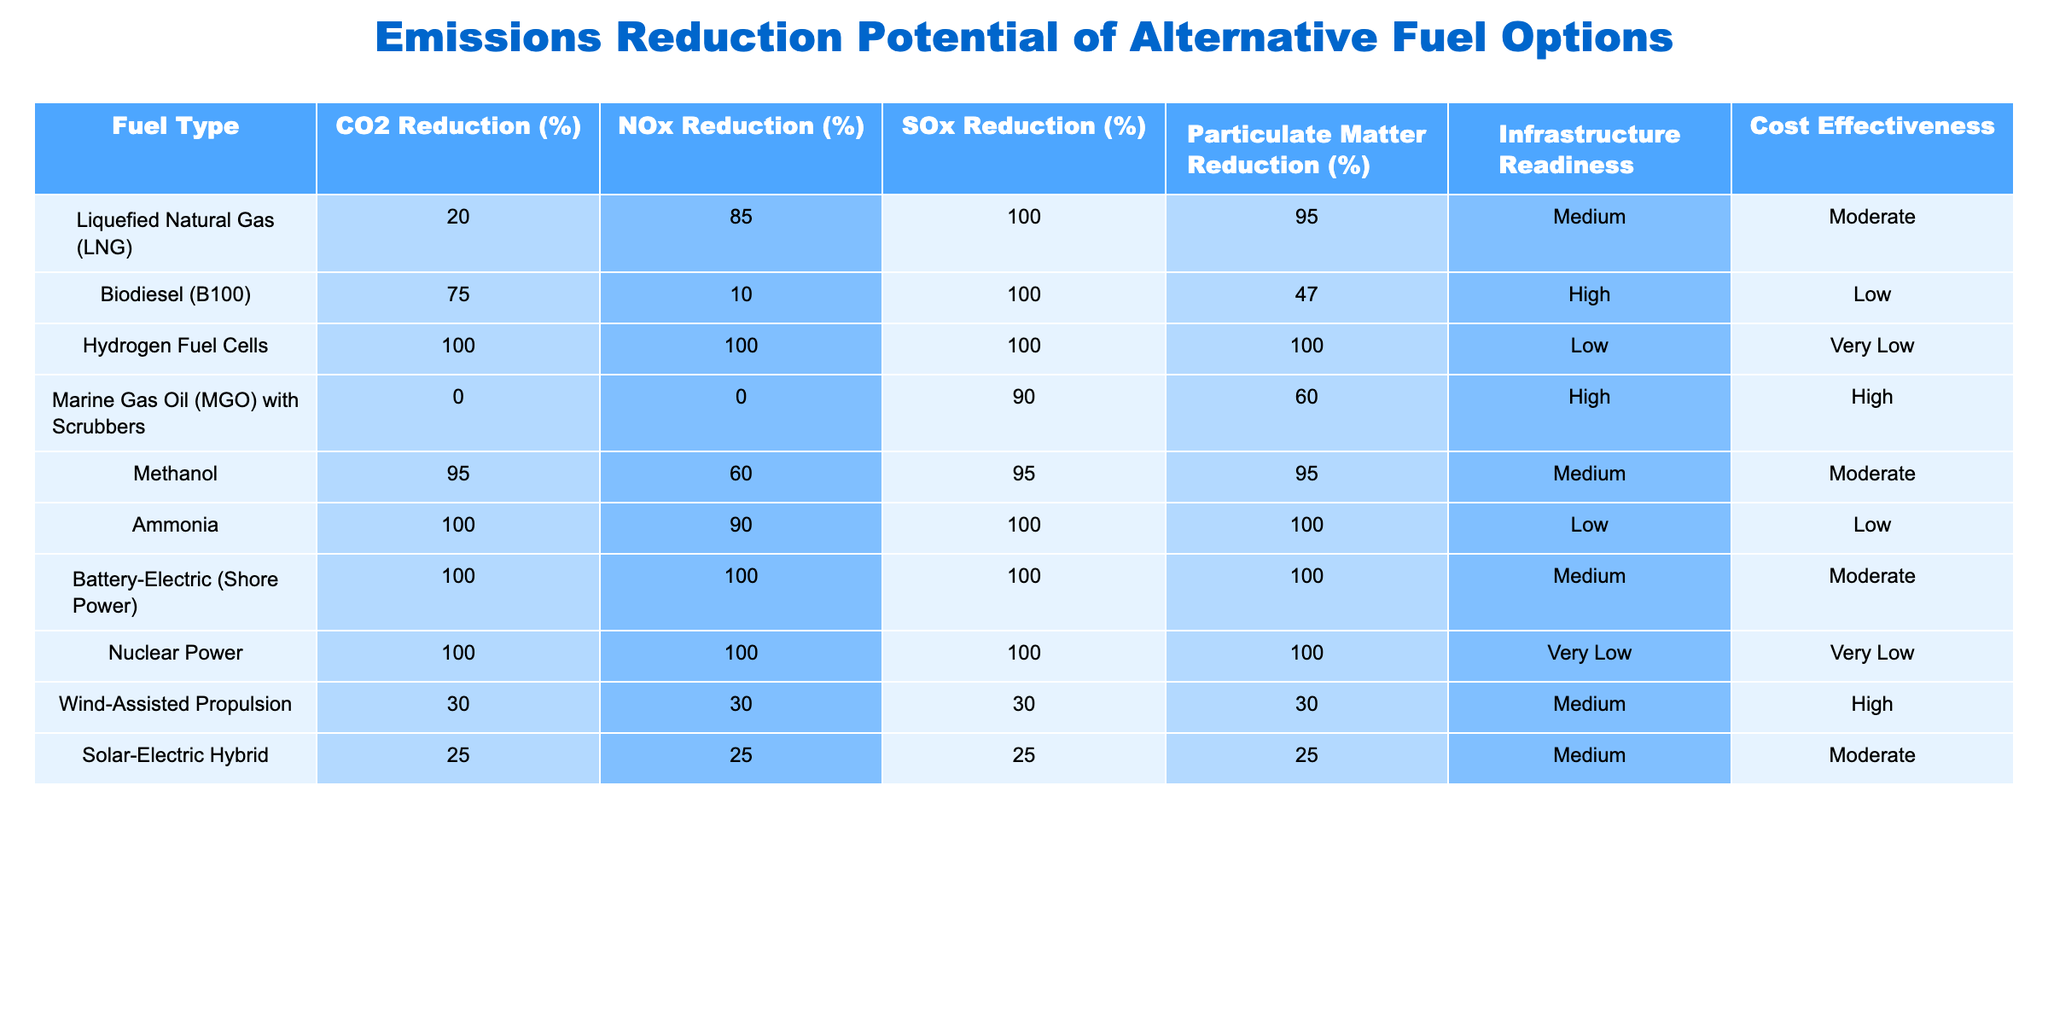What is the CO2 reduction percentage for Hydrogen Fuel Cells? The table shows that for Hydrogen Fuel Cells, the CO2 reduction percentage is listed as 100%. This value is directly found in the CO2 Reduction (%) column next to Hydrogen Fuel Cells.
Answer: 100% Which fuel option has the highest particulate matter reduction? From the table, Hydrogen Fuel Cells and Ammonia both have a particulate matter reduction of 100%. However, the highest value is the same for both, as it's the maximum achieved when looking at all the options listed.
Answer: Hydrogen Fuel Cells and Ammonia Is the infrastructure readiness for Biodiesel low? The table indicates that the infrastructure readiness for Biodiesel (B100) is categorized as High, not Low. Thus, the statement is false.
Answer: No What is the difference in SOx reduction between Marine Gas Oil with Scrubbers and Methanol? Marine Gas Oil with Scrubbers has an SOx reduction of 90% while Methanol has 95%. By calculating the difference, 95% - 90% = 5%. Therefore, the difference in SOx reduction is 5%.
Answer: 5% Which fuel types provide 100% reduction across all emission types? Upon reviewing the table, Hydrogen Fuel Cells, Ammonia, Nuclear Power, and Battery-Electric (Shore Power) all achieve a 100% reduction in CO2, NOx, SOx, and Particulate Matter. A thorough check shows that all four fuels meet this criterion.
Answer: Hydrogen Fuel Cells, Ammonia, Nuclear Power, Battery-Electric (Shore Power) What percentage of NOx reduction does Wind-Assisted Propulsion achieve? The table directly indicates that Wind-Assisted Propulsion achieves a NOx reduction of 30%. This value is clearly listed in the corresponding column for the fuel type.
Answer: 30% Does the cost effectiveness of Marine Gas Oil with Scrubbers fall under Moderate? According to the table, Marine Gas Oil with Scrubbers has a cost effectiveness rating of High. Thus, this statement is false.
Answer: No What is the average CO2 reduction percentage of all the fuel types? To find the average CO2 reduction percentage, we’ll sum the percentages: 20 + 75 + 100 + 0 + 95 + 100 + 100 + 100 + 30 + 25 = 745. There are 10 fuel types, so the average is 745 / 10 = 74.5%.
Answer: 74.5% Which fuel type has the lowest cost-effectiveness rating? The table indicates that Hydrogen Fuel Cells and Nuclear Power both have a cost effectiveness rating of Very Low. They share the lowest rating when comparing all fuel options listed.
Answer: Hydrogen Fuel Cells and Nuclear Power What is the total reduction potential of SOx from Hydrogen Fuel Cells and Ammonia? According to the table, Hydrogen Fuel Cells achieve a 100% SOx reduction, while Ammonia also achieves a 100% reduction. Adding these values together gives a total reduction potential of 100% + 100% = 200%.
Answer: 200% 